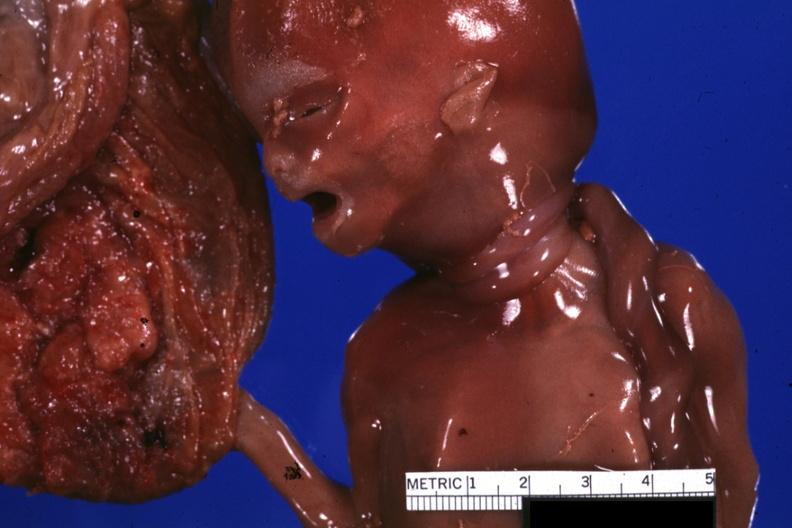what is present?
Answer the question using a single word or phrase. Stillborn cord around neck 